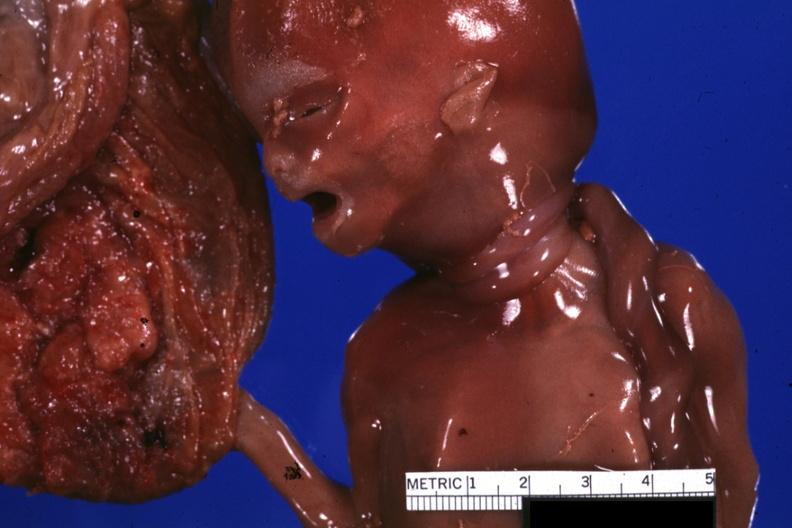what is present?
Answer the question using a single word or phrase. Stillborn cord around neck 